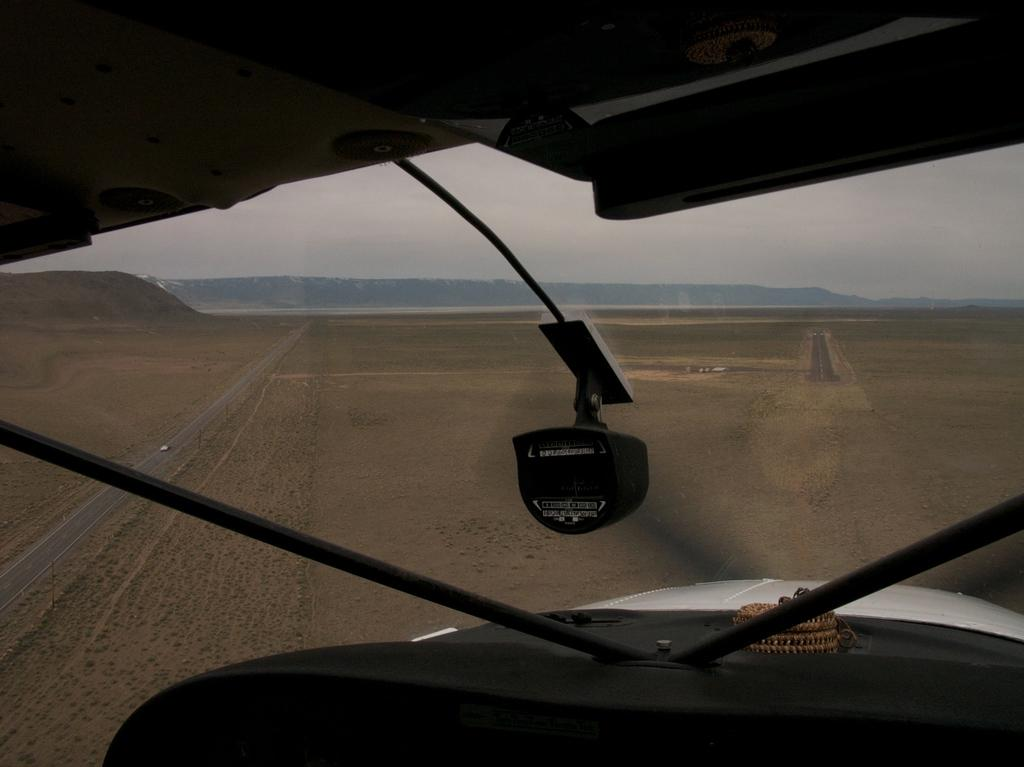What is the main subject of the image? The main subject of the image is an aircraft. What can be seen in the background of the image? There are mountains in the background of the image. What type of infrastructure is visible in the image? There are roads visible in the image. What is present on the road in the image? There is a vehicle on the road in the image. What type of terrain is visible in the image? There is sand visible in the image. What is visible at the top of the image? The sky is visible at the top of the image. What type of machine is the owl using to fly in the image? There is no owl present in the image, and therefore no such machine or activity can be observed. 